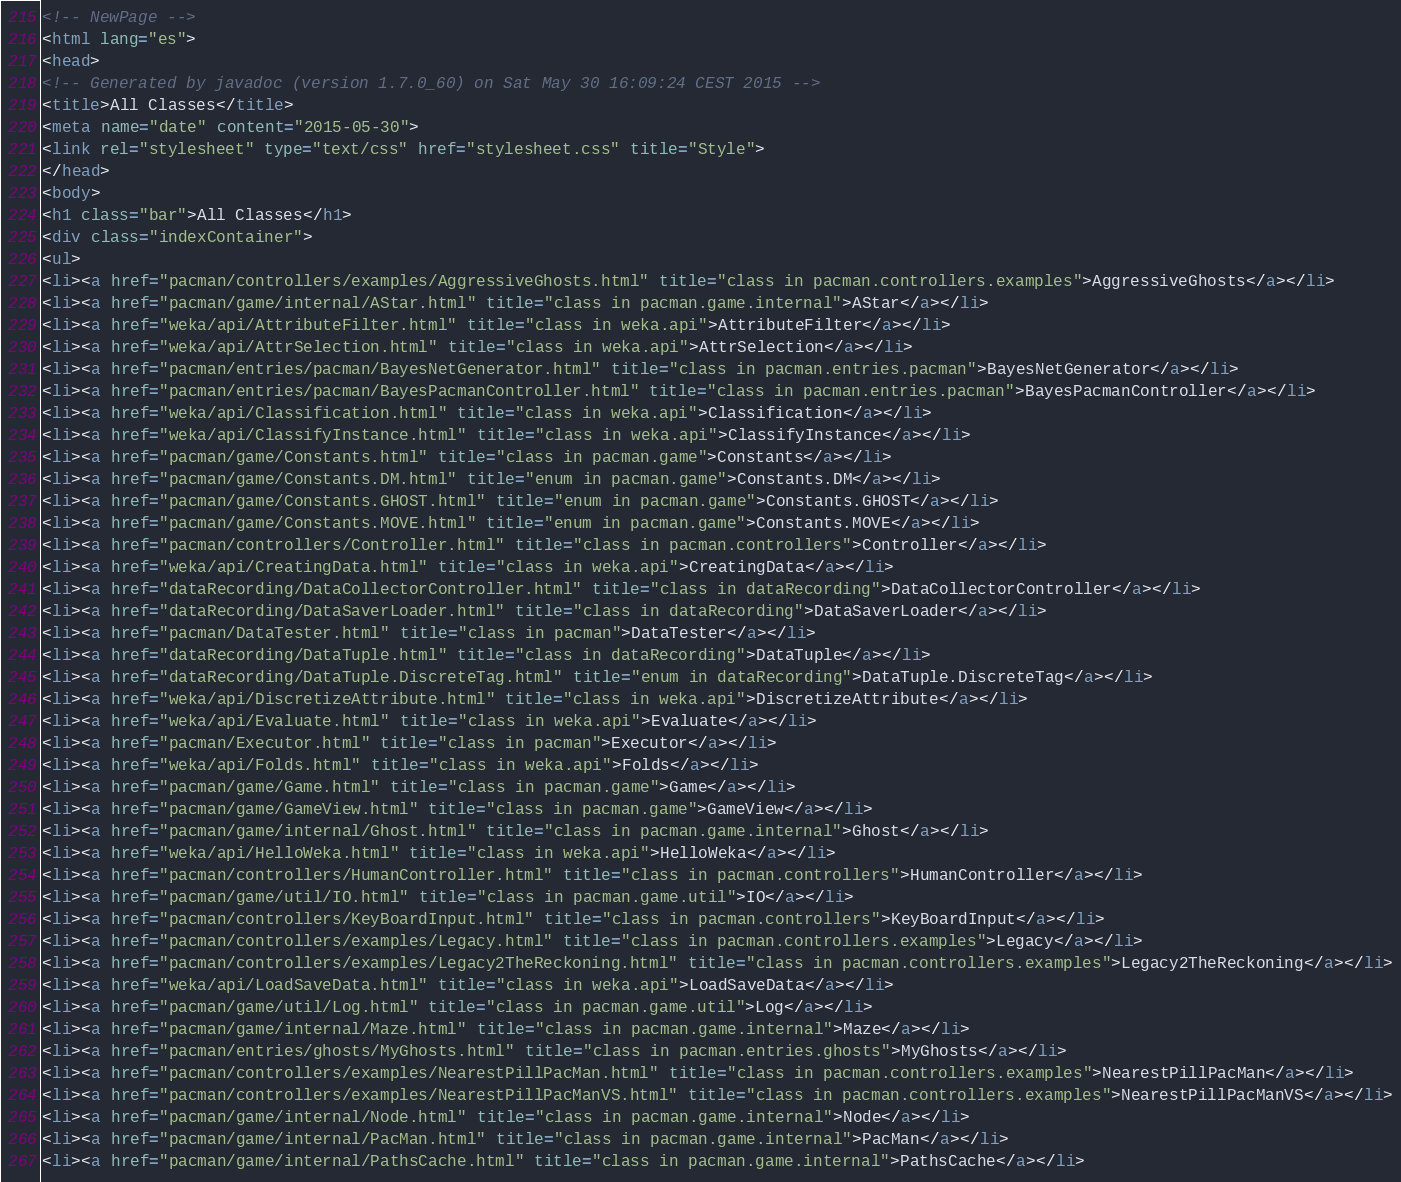<code> <loc_0><loc_0><loc_500><loc_500><_HTML_><!-- NewPage -->
<html lang="es">
<head>
<!-- Generated by javadoc (version 1.7.0_60) on Sat May 30 16:09:24 CEST 2015 -->
<title>All Classes</title>
<meta name="date" content="2015-05-30">
<link rel="stylesheet" type="text/css" href="stylesheet.css" title="Style">
</head>
<body>
<h1 class="bar">All Classes</h1>
<div class="indexContainer">
<ul>
<li><a href="pacman/controllers/examples/AggressiveGhosts.html" title="class in pacman.controllers.examples">AggressiveGhosts</a></li>
<li><a href="pacman/game/internal/AStar.html" title="class in pacman.game.internal">AStar</a></li>
<li><a href="weka/api/AttributeFilter.html" title="class in weka.api">AttributeFilter</a></li>
<li><a href="weka/api/AttrSelection.html" title="class in weka.api">AttrSelection</a></li>
<li><a href="pacman/entries/pacman/BayesNetGenerator.html" title="class in pacman.entries.pacman">BayesNetGenerator</a></li>
<li><a href="pacman/entries/pacman/BayesPacmanController.html" title="class in pacman.entries.pacman">BayesPacmanController</a></li>
<li><a href="weka/api/Classification.html" title="class in weka.api">Classification</a></li>
<li><a href="weka/api/ClassifyInstance.html" title="class in weka.api">ClassifyInstance</a></li>
<li><a href="pacman/game/Constants.html" title="class in pacman.game">Constants</a></li>
<li><a href="pacman/game/Constants.DM.html" title="enum in pacman.game">Constants.DM</a></li>
<li><a href="pacman/game/Constants.GHOST.html" title="enum in pacman.game">Constants.GHOST</a></li>
<li><a href="pacman/game/Constants.MOVE.html" title="enum in pacman.game">Constants.MOVE</a></li>
<li><a href="pacman/controllers/Controller.html" title="class in pacman.controllers">Controller</a></li>
<li><a href="weka/api/CreatingData.html" title="class in weka.api">CreatingData</a></li>
<li><a href="dataRecording/DataCollectorController.html" title="class in dataRecording">DataCollectorController</a></li>
<li><a href="dataRecording/DataSaverLoader.html" title="class in dataRecording">DataSaverLoader</a></li>
<li><a href="pacman/DataTester.html" title="class in pacman">DataTester</a></li>
<li><a href="dataRecording/DataTuple.html" title="class in dataRecording">DataTuple</a></li>
<li><a href="dataRecording/DataTuple.DiscreteTag.html" title="enum in dataRecording">DataTuple.DiscreteTag</a></li>
<li><a href="weka/api/DiscretizeAttribute.html" title="class in weka.api">DiscretizeAttribute</a></li>
<li><a href="weka/api/Evaluate.html" title="class in weka.api">Evaluate</a></li>
<li><a href="pacman/Executor.html" title="class in pacman">Executor</a></li>
<li><a href="weka/api/Folds.html" title="class in weka.api">Folds</a></li>
<li><a href="pacman/game/Game.html" title="class in pacman.game">Game</a></li>
<li><a href="pacman/game/GameView.html" title="class in pacman.game">GameView</a></li>
<li><a href="pacman/game/internal/Ghost.html" title="class in pacman.game.internal">Ghost</a></li>
<li><a href="weka/api/HelloWeka.html" title="class in weka.api">HelloWeka</a></li>
<li><a href="pacman/controllers/HumanController.html" title="class in pacman.controllers">HumanController</a></li>
<li><a href="pacman/game/util/IO.html" title="class in pacman.game.util">IO</a></li>
<li><a href="pacman/controllers/KeyBoardInput.html" title="class in pacman.controllers">KeyBoardInput</a></li>
<li><a href="pacman/controllers/examples/Legacy.html" title="class in pacman.controllers.examples">Legacy</a></li>
<li><a href="pacman/controllers/examples/Legacy2TheReckoning.html" title="class in pacman.controllers.examples">Legacy2TheReckoning</a></li>
<li><a href="weka/api/LoadSaveData.html" title="class in weka.api">LoadSaveData</a></li>
<li><a href="pacman/game/util/Log.html" title="class in pacman.game.util">Log</a></li>
<li><a href="pacman/game/internal/Maze.html" title="class in pacman.game.internal">Maze</a></li>
<li><a href="pacman/entries/ghosts/MyGhosts.html" title="class in pacman.entries.ghosts">MyGhosts</a></li>
<li><a href="pacman/controllers/examples/NearestPillPacMan.html" title="class in pacman.controllers.examples">NearestPillPacMan</a></li>
<li><a href="pacman/controllers/examples/NearestPillPacManVS.html" title="class in pacman.controllers.examples">NearestPillPacManVS</a></li>
<li><a href="pacman/game/internal/Node.html" title="class in pacman.game.internal">Node</a></li>
<li><a href="pacman/game/internal/PacMan.html" title="class in pacman.game.internal">PacMan</a></li>
<li><a href="pacman/game/internal/PathsCache.html" title="class in pacman.game.internal">PathsCache</a></li></code> 